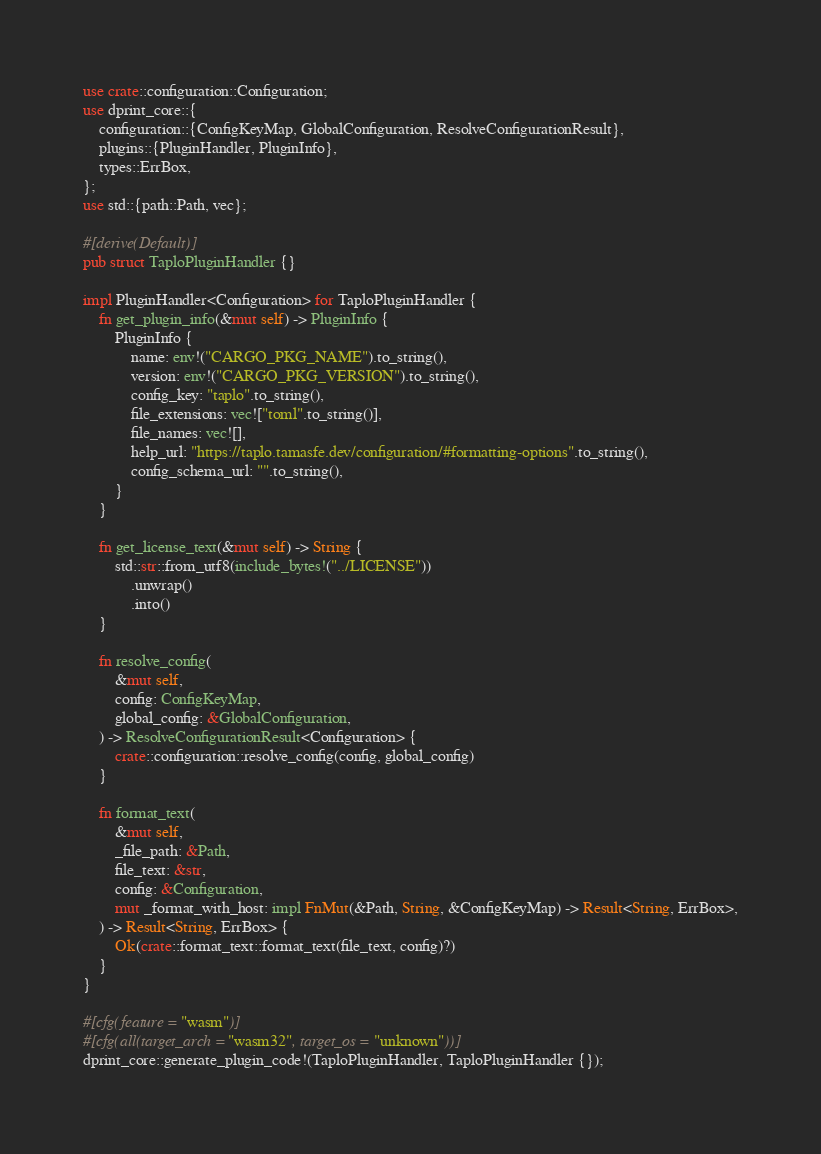<code> <loc_0><loc_0><loc_500><loc_500><_Rust_>use crate::configuration::Configuration;
use dprint_core::{
    configuration::{ConfigKeyMap, GlobalConfiguration, ResolveConfigurationResult},
    plugins::{PluginHandler, PluginInfo},
    types::ErrBox,
};
use std::{path::Path, vec};

#[derive(Default)]
pub struct TaploPluginHandler {}

impl PluginHandler<Configuration> for TaploPluginHandler {
    fn get_plugin_info(&mut self) -> PluginInfo {
        PluginInfo {
            name: env!("CARGO_PKG_NAME").to_string(),
            version: env!("CARGO_PKG_VERSION").to_string(),
            config_key: "taplo".to_string(),
            file_extensions: vec!["toml".to_string()],
            file_names: vec![],
            help_url: "https://taplo.tamasfe.dev/configuration/#formatting-options".to_string(),
            config_schema_url: "".to_string(),
        }
    }

    fn get_license_text(&mut self) -> String {
        std::str::from_utf8(include_bytes!("../LICENSE"))
            .unwrap()
            .into()
    }

    fn resolve_config(
        &mut self,
        config: ConfigKeyMap,
        global_config: &GlobalConfiguration,
    ) -> ResolveConfigurationResult<Configuration> {
        crate::configuration::resolve_config(config, global_config)
    }

    fn format_text(
        &mut self,
        _file_path: &Path,
        file_text: &str,
        config: &Configuration,
        mut _format_with_host: impl FnMut(&Path, String, &ConfigKeyMap) -> Result<String, ErrBox>,
    ) -> Result<String, ErrBox> {
        Ok(crate::format_text::format_text(file_text, config)?)
    }
}

#[cfg(feature = "wasm")]
#[cfg(all(target_arch = "wasm32", target_os = "unknown"))]
dprint_core::generate_plugin_code!(TaploPluginHandler, TaploPluginHandler {});
</code> 